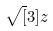<formula> <loc_0><loc_0><loc_500><loc_500>\sqrt { [ } 3 ] { z }</formula> 